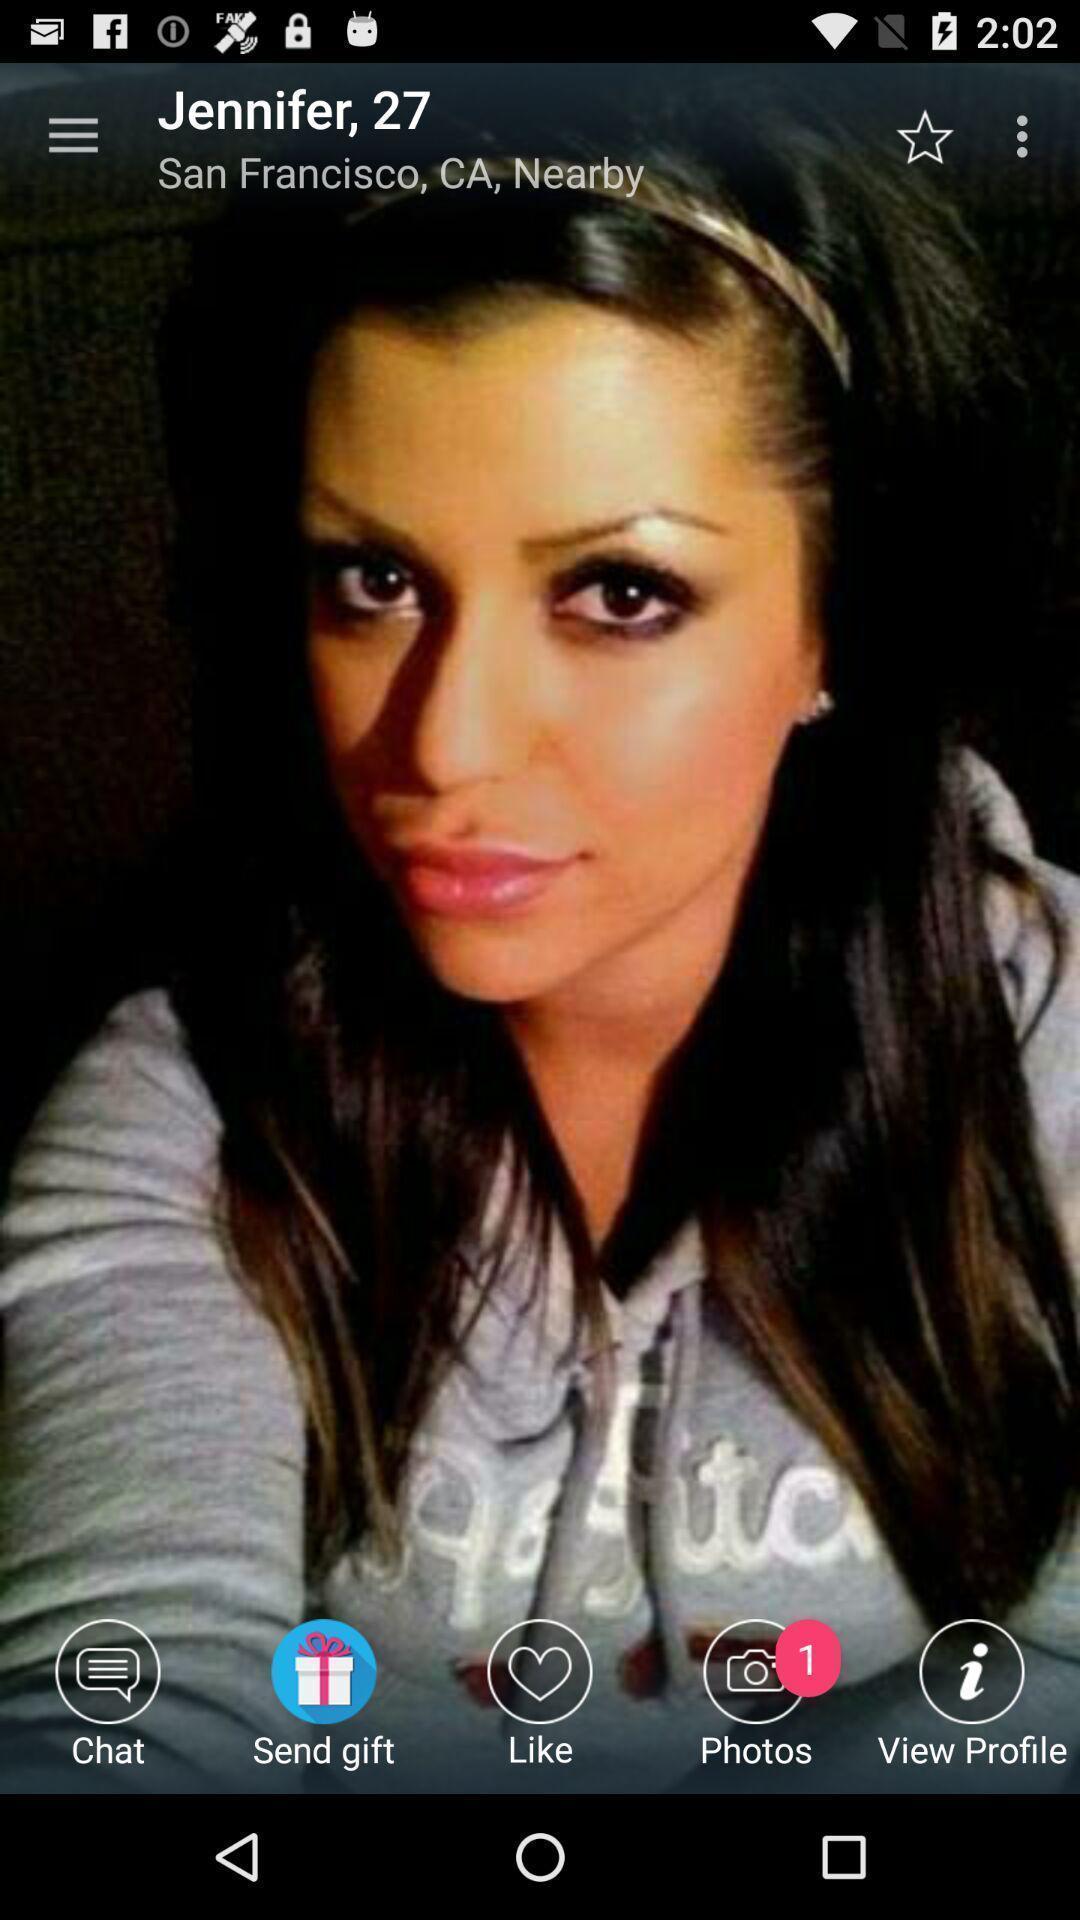Please provide a description for this image. Page showing various options of social media app. 